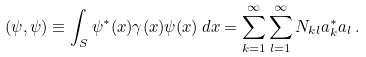<formula> <loc_0><loc_0><loc_500><loc_500>( \psi , \psi ) \equiv \int _ { S } \psi ^ { * } ( x ) \gamma ( x ) \psi ( x ) \, d x = \sum _ { k = 1 } ^ { \infty } \sum _ { l = 1 } ^ { \infty } N _ { k l } a _ { k } ^ { * } a _ { l } \, .</formula> 